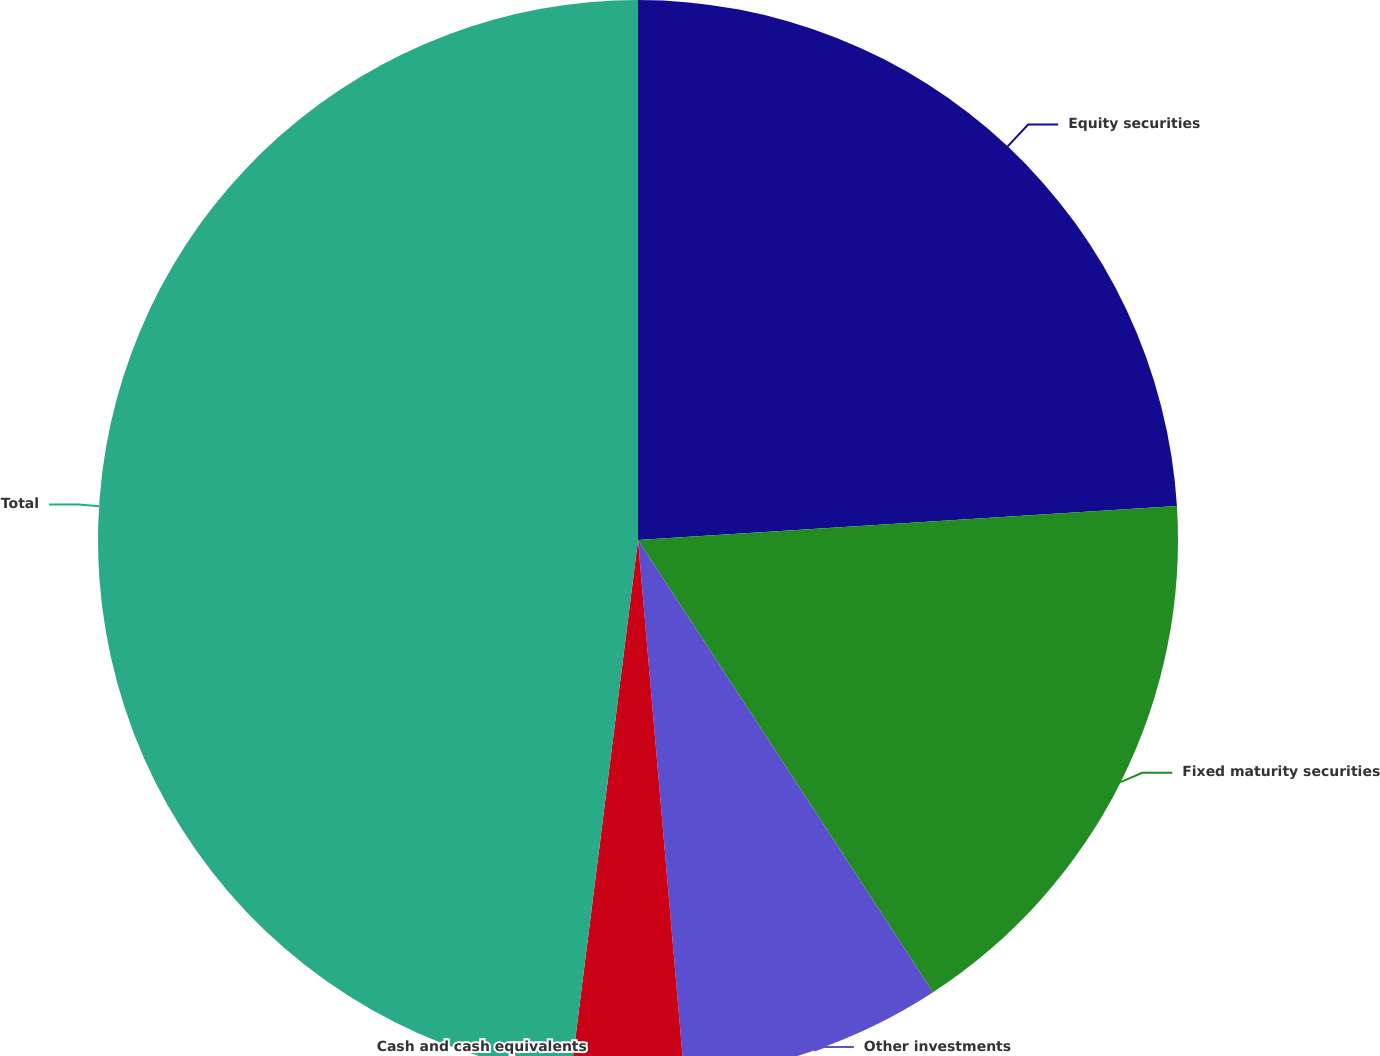Convert chart to OTSL. <chart><loc_0><loc_0><loc_500><loc_500><pie_chart><fcel>Equity securities<fcel>Fixed maturity securities<fcel>Other investments<fcel>Cash and cash equivalents<fcel>Total<nl><fcel>24.0%<fcel>16.8%<fcel>7.83%<fcel>3.36%<fcel>48.01%<nl></chart> 